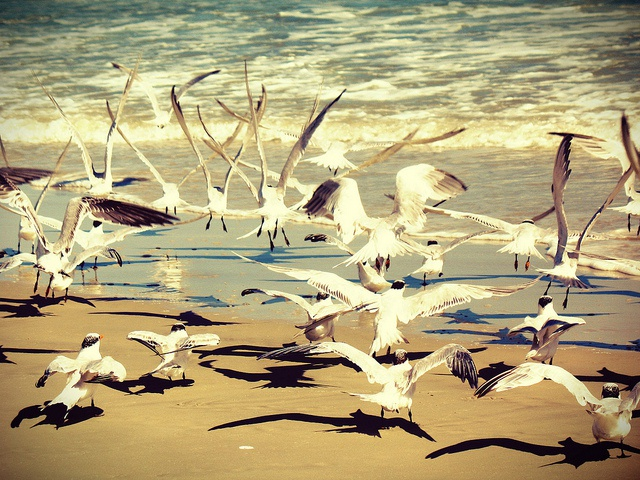Describe the objects in this image and their specific colors. I can see bird in black, khaki, lightyellow, and tan tones, bird in black, lightyellow, khaki, tan, and gray tones, bird in black, lightyellow, khaki, and tan tones, bird in black, lightyellow, khaki, and tan tones, and bird in black, khaki, lightyellow, and tan tones in this image. 